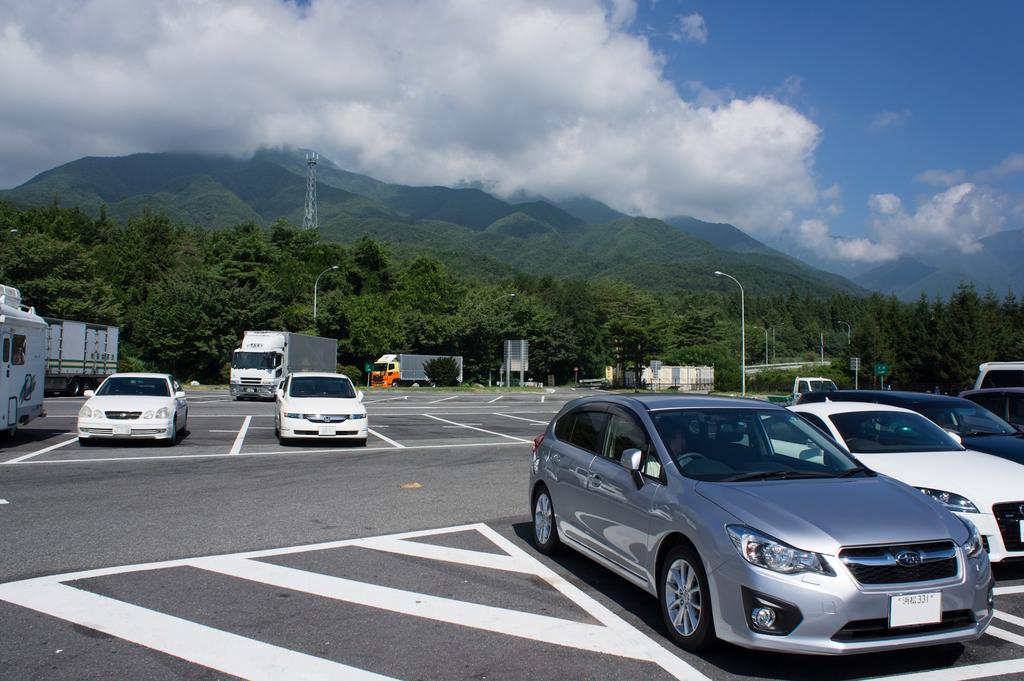What can be seen on the road in the image? There are vehicles on the road in the image. What is visible in the background of the image? There are poles, trees, a tower, hills, and the sky visible in the background of the image. Can you tell me how many times the vehicles have kicked a ball in the image? There is no indication of any vehicles kicking a ball in the image. What type of muscle is visible on the tower in the image? There is no muscle visible on the tower in the image; it is a structure, not a living organism. 